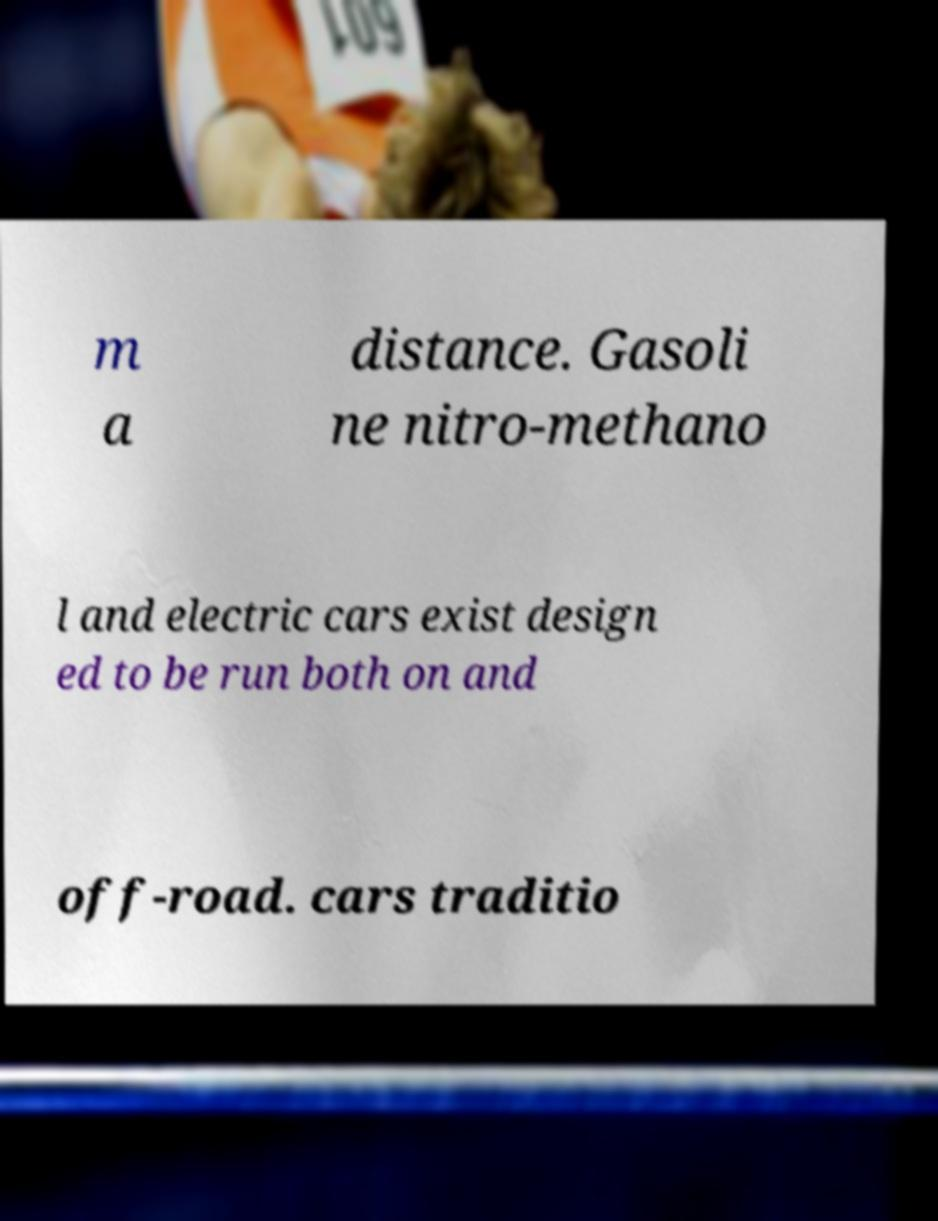For documentation purposes, I need the text within this image transcribed. Could you provide that? m a distance. Gasoli ne nitro-methano l and electric cars exist design ed to be run both on and off-road. cars traditio 